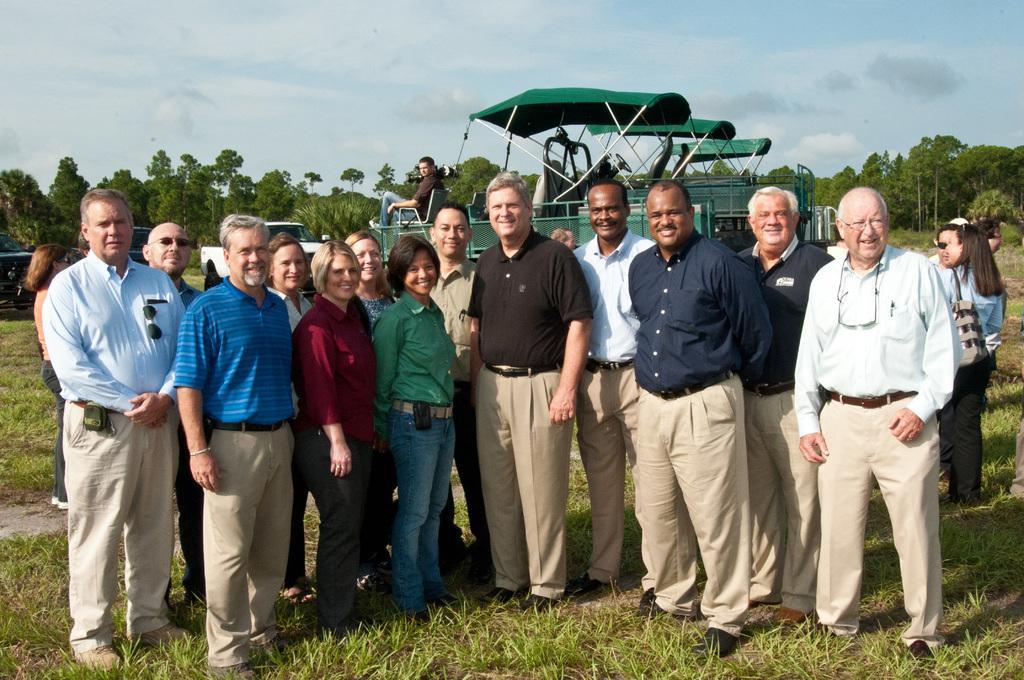Could you give a brief overview of what you see in this image? This picture is taken from outside of the city. In this image, in the middle, we can see a group of people standing on the grass. In the background, we can see a vehicle, in the vehicle, we can see a man sitting on it. In the background, we can see some trees, plants. At the top, we can see a sky which is a bit cloudy, at the bottom, we can see some plants and a grass. 